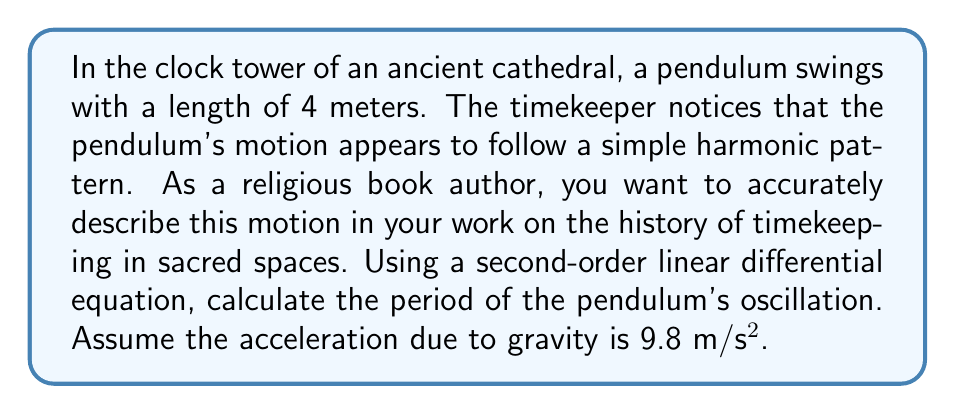Can you answer this question? To solve this problem, we'll follow these steps:

1) The motion of a simple pendulum can be described by the following second-order linear differential equation:

   $$\frac{d^2\theta}{dt^2} + \frac{g}{L}\theta = 0$$

   where $\theta$ is the angular displacement, $t$ is time, $g$ is the acceleration due to gravity, and $L$ is the length of the pendulum.

2) The general solution to this equation is:

   $$\theta(t) = A\cos(\omega t) + B\sin(\omega t)$$

   where $\omega = \sqrt{\frac{g}{L}}$ is the angular frequency of the oscillation.

3) The period $T$ of the oscillation is related to the angular frequency by:

   $$T = \frac{2\pi}{\omega}$$

4) Substituting the expression for $\omega$:

   $$T = 2\pi\sqrt{\frac{L}{g}}$$

5) Now, we can plug in our known values:
   $L = 4$ meters
   $g = 9.8$ m/s²

   $$T = 2\pi\sqrt{\frac{4}{9.8}}$$

6) Simplifying:

   $$T = 2\pi\sqrt{\frac{10}{49}} \approx 4.01 \text{ seconds}$$
Answer: The period of the pendulum's oscillation is approximately 4.01 seconds. 